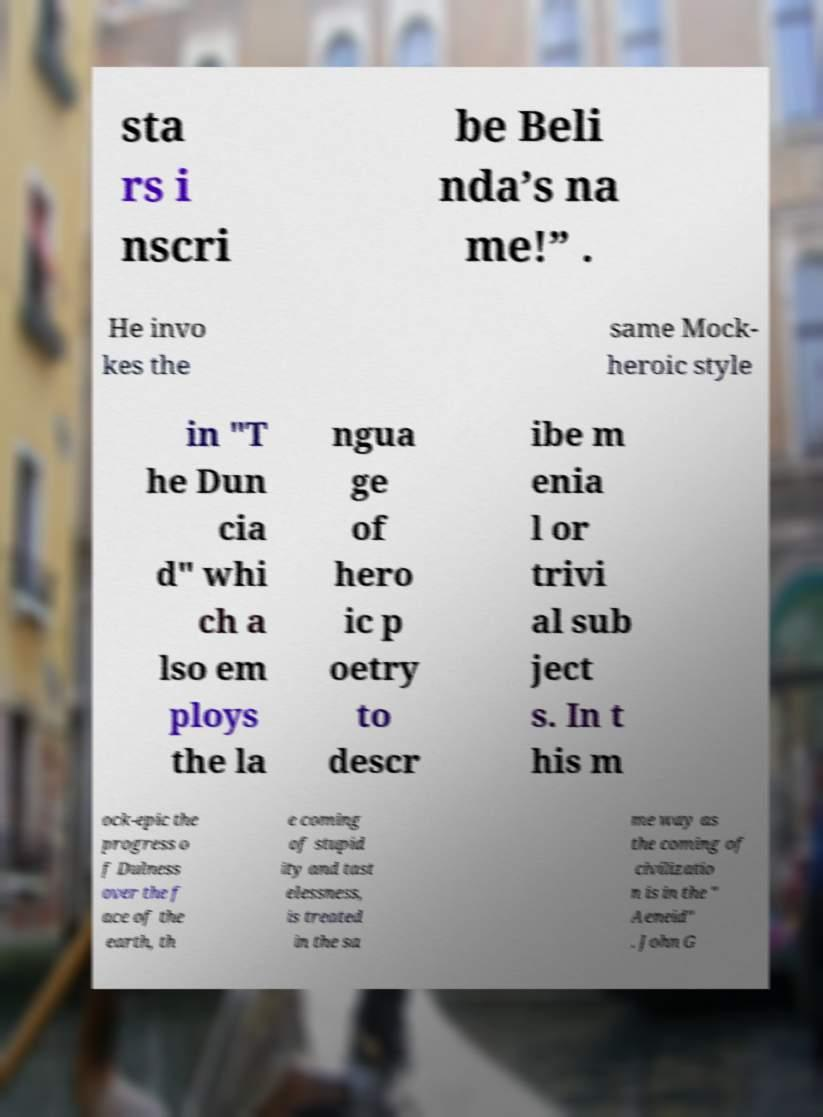Please read and relay the text visible in this image. What does it say? sta rs i nscri be Beli nda’s na me!” . He invo kes the same Mock- heroic style in "T he Dun cia d" whi ch a lso em ploys the la ngua ge of hero ic p oetry to descr ibe m enia l or trivi al sub ject s. In t his m ock-epic the progress o f Dulness over the f ace of the earth, th e coming of stupid ity and tast elessness, is treated in the sa me way as the coming of civilizatio n is in the " Aeneid" . John G 